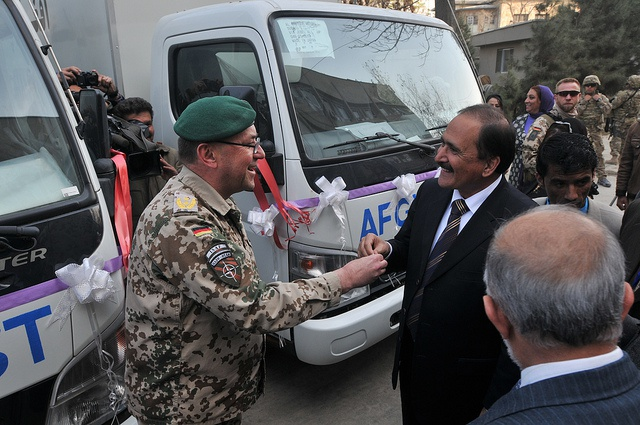Describe the objects in this image and their specific colors. I can see truck in gray, darkgray, black, and lightgray tones, truck in gray, black, darkgray, and lightgray tones, people in gray, black, and darkgray tones, people in gray, black, brown, and maroon tones, and people in gray and black tones in this image. 